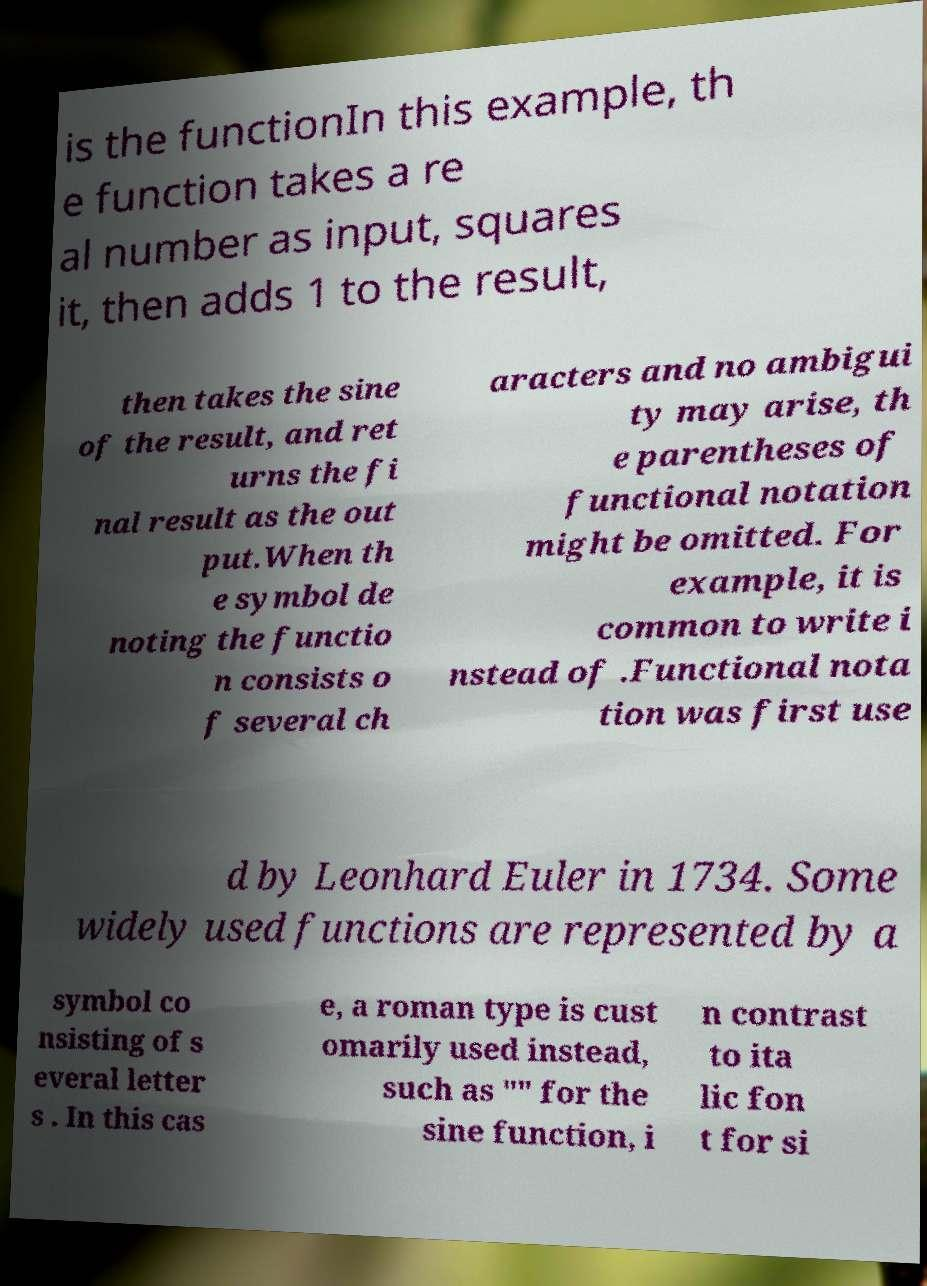Please identify and transcribe the text found in this image. is the functionIn this example, th e function takes a re al number as input, squares it, then adds 1 to the result, then takes the sine of the result, and ret urns the fi nal result as the out put.When th e symbol de noting the functio n consists o f several ch aracters and no ambigui ty may arise, th e parentheses of functional notation might be omitted. For example, it is common to write i nstead of .Functional nota tion was first use d by Leonhard Euler in 1734. Some widely used functions are represented by a symbol co nsisting of s everal letter s . In this cas e, a roman type is cust omarily used instead, such as "" for the sine function, i n contrast to ita lic fon t for si 